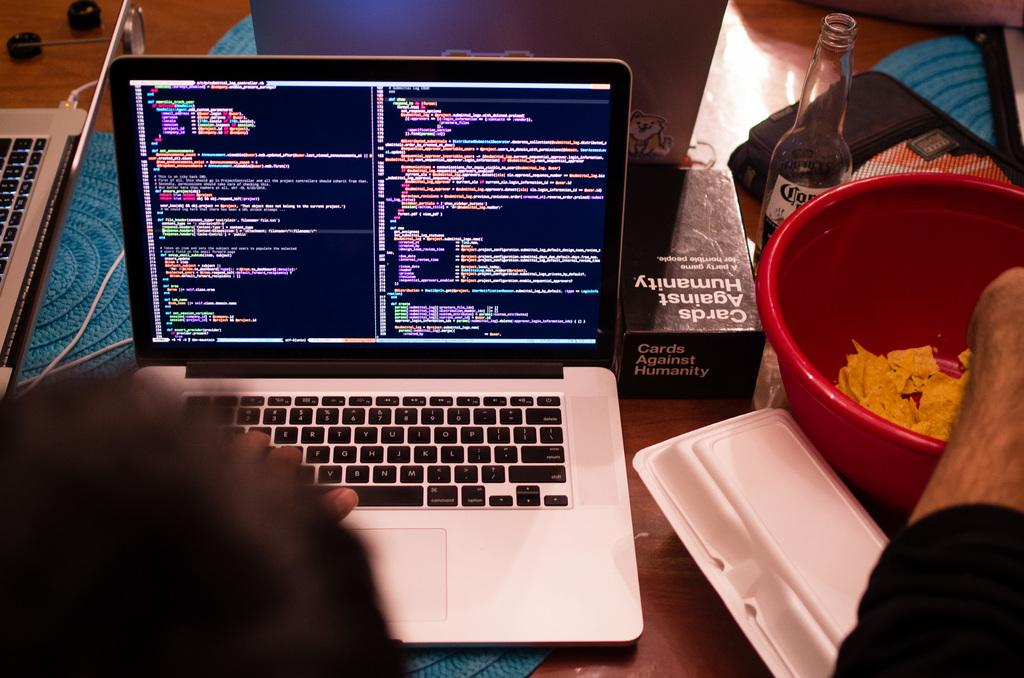<image>
Offer a succinct explanation of the picture presented. Person using a laptop next to a box of Cards Against Humanity games. 